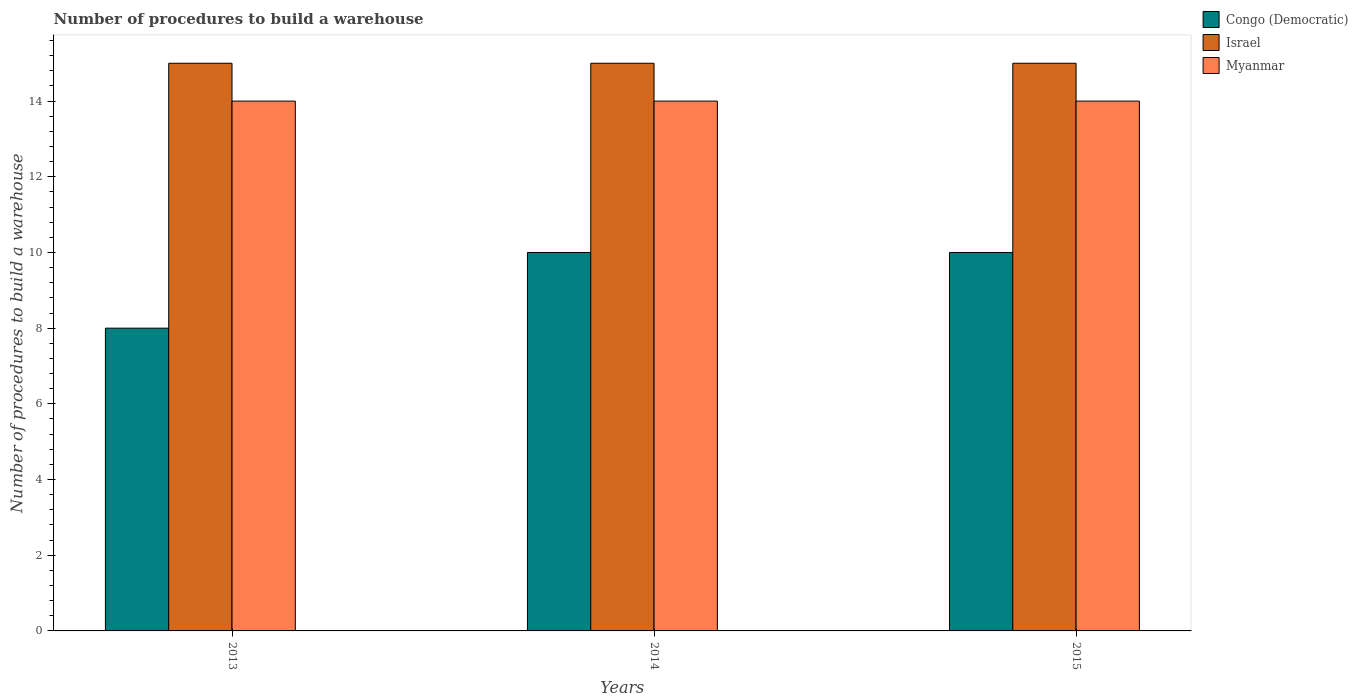Are the number of bars on each tick of the X-axis equal?
Ensure brevity in your answer.  Yes. How many bars are there on the 2nd tick from the left?
Give a very brief answer. 3. How many bars are there on the 1st tick from the right?
Your answer should be very brief. 3. What is the label of the 2nd group of bars from the left?
Give a very brief answer. 2014. What is the number of procedures to build a warehouse in in Congo (Democratic) in 2014?
Your answer should be very brief. 10. Across all years, what is the maximum number of procedures to build a warehouse in in Israel?
Keep it short and to the point. 15. Across all years, what is the minimum number of procedures to build a warehouse in in Congo (Democratic)?
Give a very brief answer. 8. What is the total number of procedures to build a warehouse in in Congo (Democratic) in the graph?
Keep it short and to the point. 28. What is the difference between the number of procedures to build a warehouse in in Congo (Democratic) in 2014 and that in 2015?
Provide a short and direct response. 0. What is the difference between the number of procedures to build a warehouse in in Myanmar in 2014 and the number of procedures to build a warehouse in in Congo (Democratic) in 2013?
Offer a terse response. 6. In the year 2015, what is the difference between the number of procedures to build a warehouse in in Congo (Democratic) and number of procedures to build a warehouse in in Israel?
Provide a short and direct response. -5. In how many years, is the number of procedures to build a warehouse in in Myanmar greater than 8?
Provide a short and direct response. 3. Is the difference between the number of procedures to build a warehouse in in Congo (Democratic) in 2014 and 2015 greater than the difference between the number of procedures to build a warehouse in in Israel in 2014 and 2015?
Provide a succinct answer. No. What is the difference between the highest and the second highest number of procedures to build a warehouse in in Myanmar?
Ensure brevity in your answer.  0. What is the difference between the highest and the lowest number of procedures to build a warehouse in in Congo (Democratic)?
Provide a short and direct response. 2. Is the sum of the number of procedures to build a warehouse in in Myanmar in 2013 and 2014 greater than the maximum number of procedures to build a warehouse in in Israel across all years?
Keep it short and to the point. Yes. What does the 1st bar from the left in 2014 represents?
Your response must be concise. Congo (Democratic). What does the 3rd bar from the right in 2015 represents?
Give a very brief answer. Congo (Democratic). Is it the case that in every year, the sum of the number of procedures to build a warehouse in in Israel and number of procedures to build a warehouse in in Myanmar is greater than the number of procedures to build a warehouse in in Congo (Democratic)?
Your answer should be very brief. Yes. How many bars are there?
Your answer should be compact. 9. How many years are there in the graph?
Make the answer very short. 3. What is the difference between two consecutive major ticks on the Y-axis?
Your answer should be compact. 2. Are the values on the major ticks of Y-axis written in scientific E-notation?
Give a very brief answer. No. Does the graph contain grids?
Your answer should be compact. No. How many legend labels are there?
Provide a short and direct response. 3. How are the legend labels stacked?
Your answer should be very brief. Vertical. What is the title of the graph?
Provide a succinct answer. Number of procedures to build a warehouse. Does "Bosnia and Herzegovina" appear as one of the legend labels in the graph?
Provide a short and direct response. No. What is the label or title of the Y-axis?
Provide a succinct answer. Number of procedures to build a warehouse. What is the Number of procedures to build a warehouse of Myanmar in 2013?
Offer a very short reply. 14. What is the Number of procedures to build a warehouse of Congo (Democratic) in 2014?
Provide a succinct answer. 10. Across all years, what is the maximum Number of procedures to build a warehouse of Israel?
Your response must be concise. 15. Across all years, what is the minimum Number of procedures to build a warehouse in Congo (Democratic)?
Offer a very short reply. 8. What is the difference between the Number of procedures to build a warehouse of Myanmar in 2013 and that in 2014?
Make the answer very short. 0. What is the difference between the Number of procedures to build a warehouse of Congo (Democratic) in 2013 and that in 2015?
Your response must be concise. -2. What is the difference between the Number of procedures to build a warehouse in Congo (Democratic) in 2014 and that in 2015?
Provide a succinct answer. 0. What is the difference between the Number of procedures to build a warehouse of Congo (Democratic) in 2013 and the Number of procedures to build a warehouse of Myanmar in 2014?
Ensure brevity in your answer.  -6. What is the difference between the Number of procedures to build a warehouse of Israel in 2013 and the Number of procedures to build a warehouse of Myanmar in 2014?
Give a very brief answer. 1. What is the difference between the Number of procedures to build a warehouse of Congo (Democratic) in 2013 and the Number of procedures to build a warehouse of Israel in 2015?
Give a very brief answer. -7. What is the difference between the Number of procedures to build a warehouse of Congo (Democratic) in 2013 and the Number of procedures to build a warehouse of Myanmar in 2015?
Offer a very short reply. -6. What is the difference between the Number of procedures to build a warehouse in Israel in 2013 and the Number of procedures to build a warehouse in Myanmar in 2015?
Make the answer very short. 1. What is the difference between the Number of procedures to build a warehouse in Congo (Democratic) in 2014 and the Number of procedures to build a warehouse in Myanmar in 2015?
Make the answer very short. -4. What is the average Number of procedures to build a warehouse of Congo (Democratic) per year?
Give a very brief answer. 9.33. In the year 2013, what is the difference between the Number of procedures to build a warehouse of Congo (Democratic) and Number of procedures to build a warehouse of Myanmar?
Offer a terse response. -6. In the year 2013, what is the difference between the Number of procedures to build a warehouse of Israel and Number of procedures to build a warehouse of Myanmar?
Provide a short and direct response. 1. In the year 2014, what is the difference between the Number of procedures to build a warehouse of Congo (Democratic) and Number of procedures to build a warehouse of Israel?
Ensure brevity in your answer.  -5. What is the ratio of the Number of procedures to build a warehouse in Myanmar in 2013 to that in 2014?
Your response must be concise. 1. What is the ratio of the Number of procedures to build a warehouse of Congo (Democratic) in 2013 to that in 2015?
Your answer should be very brief. 0.8. What is the ratio of the Number of procedures to build a warehouse in Congo (Democratic) in 2014 to that in 2015?
Ensure brevity in your answer.  1. What is the ratio of the Number of procedures to build a warehouse of Myanmar in 2014 to that in 2015?
Offer a very short reply. 1. What is the difference between the highest and the second highest Number of procedures to build a warehouse of Myanmar?
Make the answer very short. 0. What is the difference between the highest and the lowest Number of procedures to build a warehouse of Congo (Democratic)?
Keep it short and to the point. 2. 